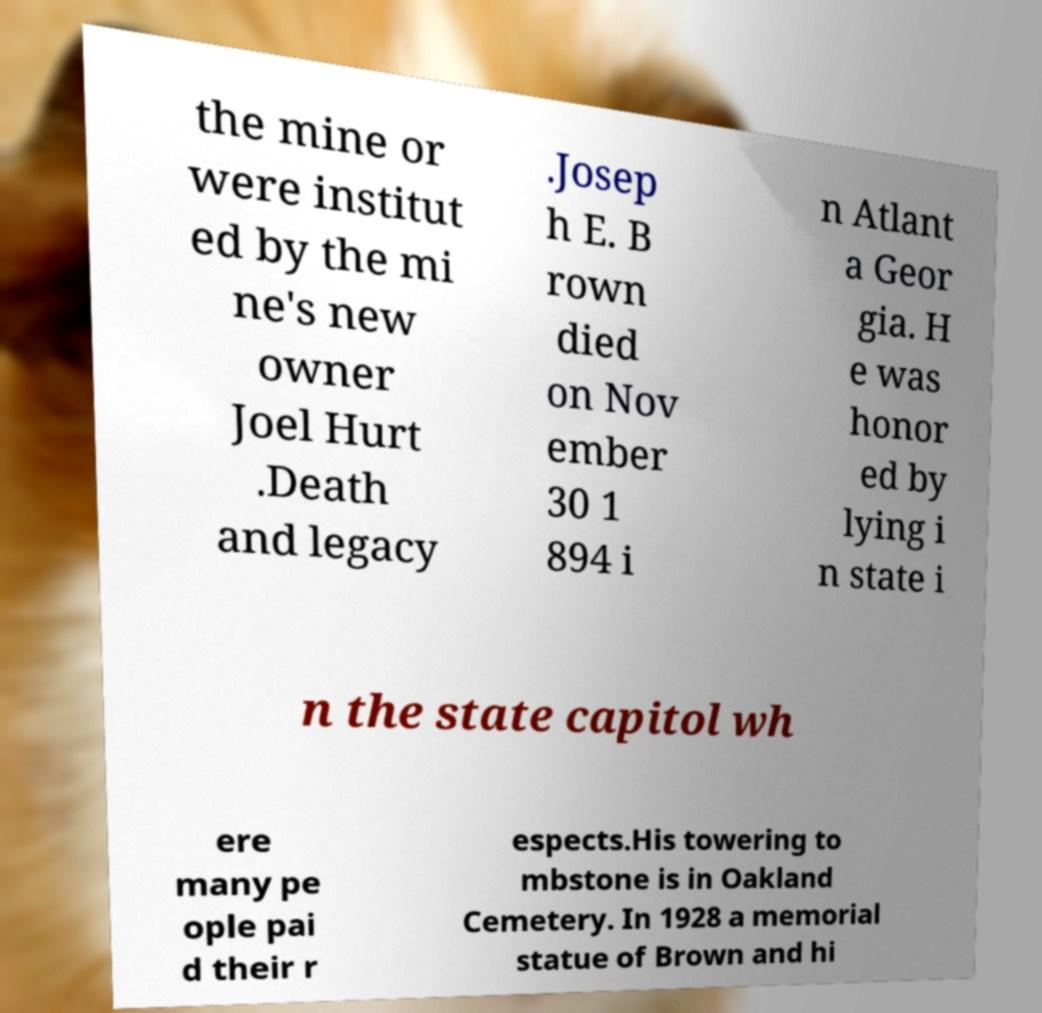There's text embedded in this image that I need extracted. Can you transcribe it verbatim? the mine or were institut ed by the mi ne's new owner Joel Hurt .Death and legacy .Josep h E. B rown died on Nov ember 30 1 894 i n Atlant a Geor gia. H e was honor ed by lying i n state i n the state capitol wh ere many pe ople pai d their r espects.His towering to mbstone is in Oakland Cemetery. In 1928 a memorial statue of Brown and hi 